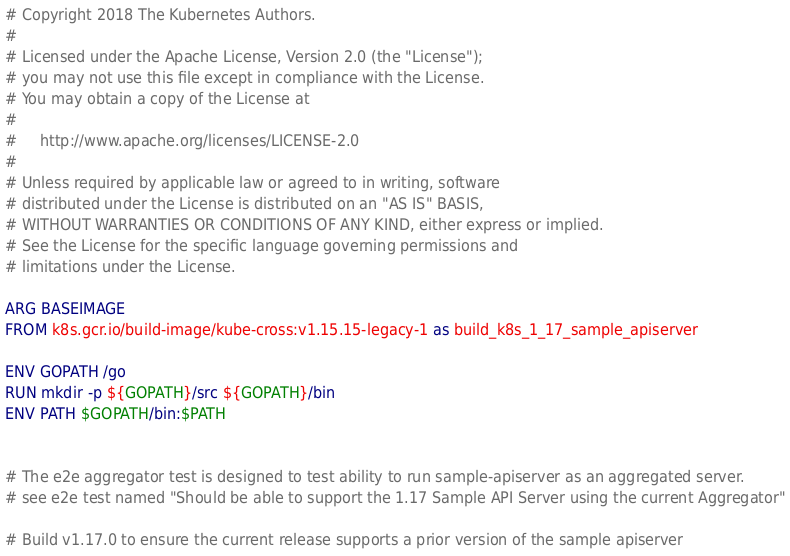<code> <loc_0><loc_0><loc_500><loc_500><_Dockerfile_># Copyright 2018 The Kubernetes Authors.
#
# Licensed under the Apache License, Version 2.0 (the "License");
# you may not use this file except in compliance with the License.
# You may obtain a copy of the License at
#
#     http://www.apache.org/licenses/LICENSE-2.0
#
# Unless required by applicable law or agreed to in writing, software
# distributed under the License is distributed on an "AS IS" BASIS,
# WITHOUT WARRANTIES OR CONDITIONS OF ANY KIND, either express or implied.
# See the License for the specific language governing permissions and
# limitations under the License.

ARG BASEIMAGE
FROM k8s.gcr.io/build-image/kube-cross:v1.15.15-legacy-1 as build_k8s_1_17_sample_apiserver

ENV GOPATH /go
RUN mkdir -p ${GOPATH}/src ${GOPATH}/bin
ENV PATH $GOPATH/bin:$PATH


# The e2e aggregator test is designed to test ability to run sample-apiserver as an aggregated server.
# see e2e test named "Should be able to support the 1.17 Sample API Server using the current Aggregator"

# Build v1.17.0 to ensure the current release supports a prior version of the sample apiserver</code> 